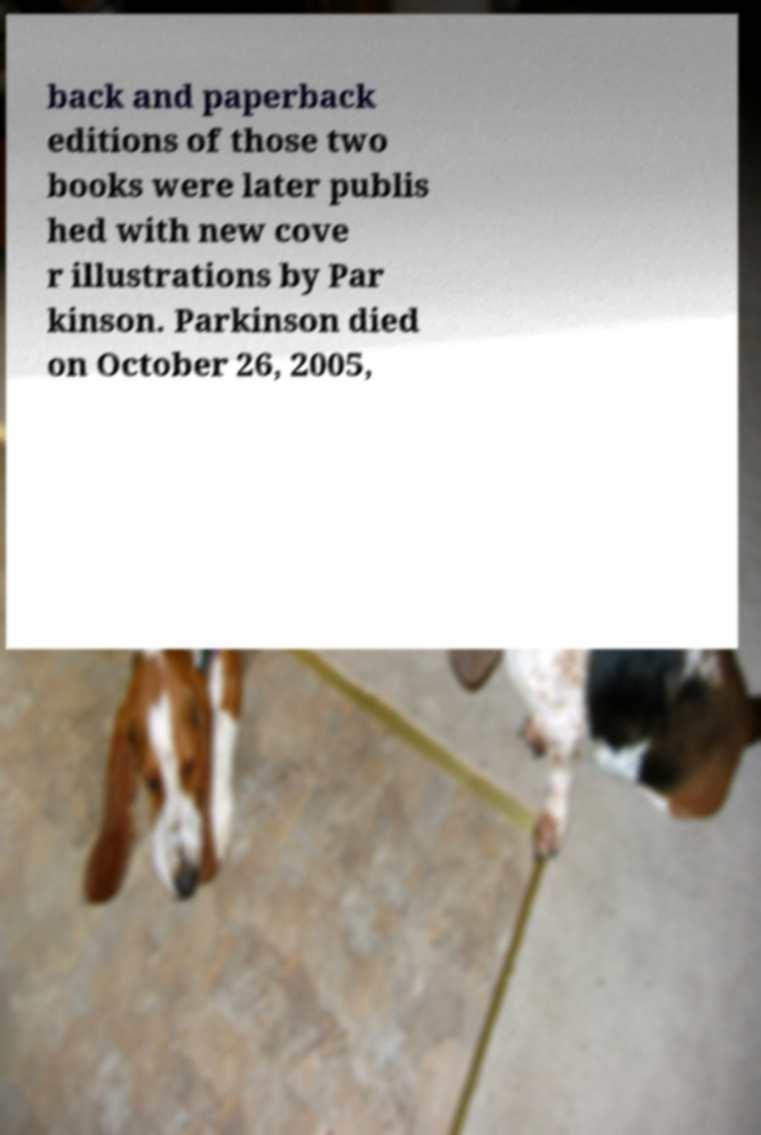Please read and relay the text visible in this image. What does it say? back and paperback editions of those two books were later publis hed with new cove r illustrations by Par kinson. Parkinson died on October 26, 2005, 